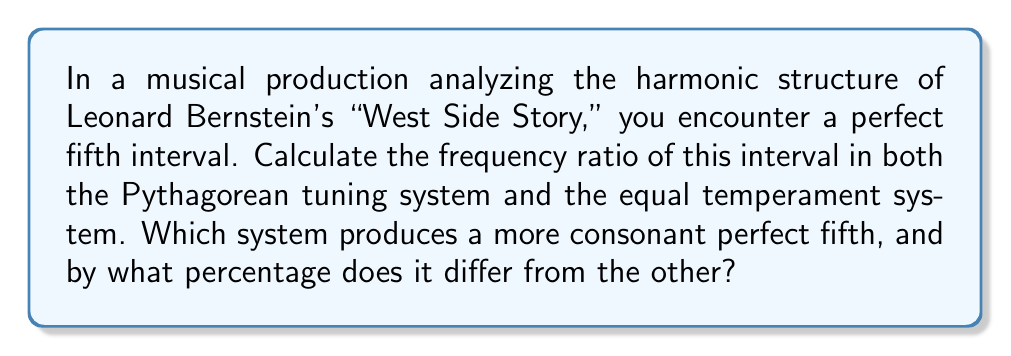Can you answer this question? Let's approach this step-by-step:

1) Perfect fifth in Pythagorean tuning:
   In Pythagorean tuning, a perfect fifth is represented by the ratio 3:2.
   Frequency ratio = $\frac{3}{2} = 1.5$

2) Perfect fifth in equal temperament:
   In equal temperament, an octave is divided into 12 equal semitones.
   A perfect fifth is 7 semitones.
   Frequency ratio = $2^{\frac{7}{12}} \approx 1.4983$

3) Comparing the two ratios:
   Pythagorean: 1.5
   Equal temperament: 1.4983

4) Calculate the percentage difference:
   $$\text{Difference} = \frac{1.5 - 1.4983}{1.4983} \times 100\% \approx 0.1134\%$$

5) The Pythagorean tuning produces a slightly larger (and more consonant) perfect fifth.
Answer: Pythagorean fifth: 1.5; Equal temperament fifth: 1.4983; Pythagorean is 0.1134% larger and more consonant. 